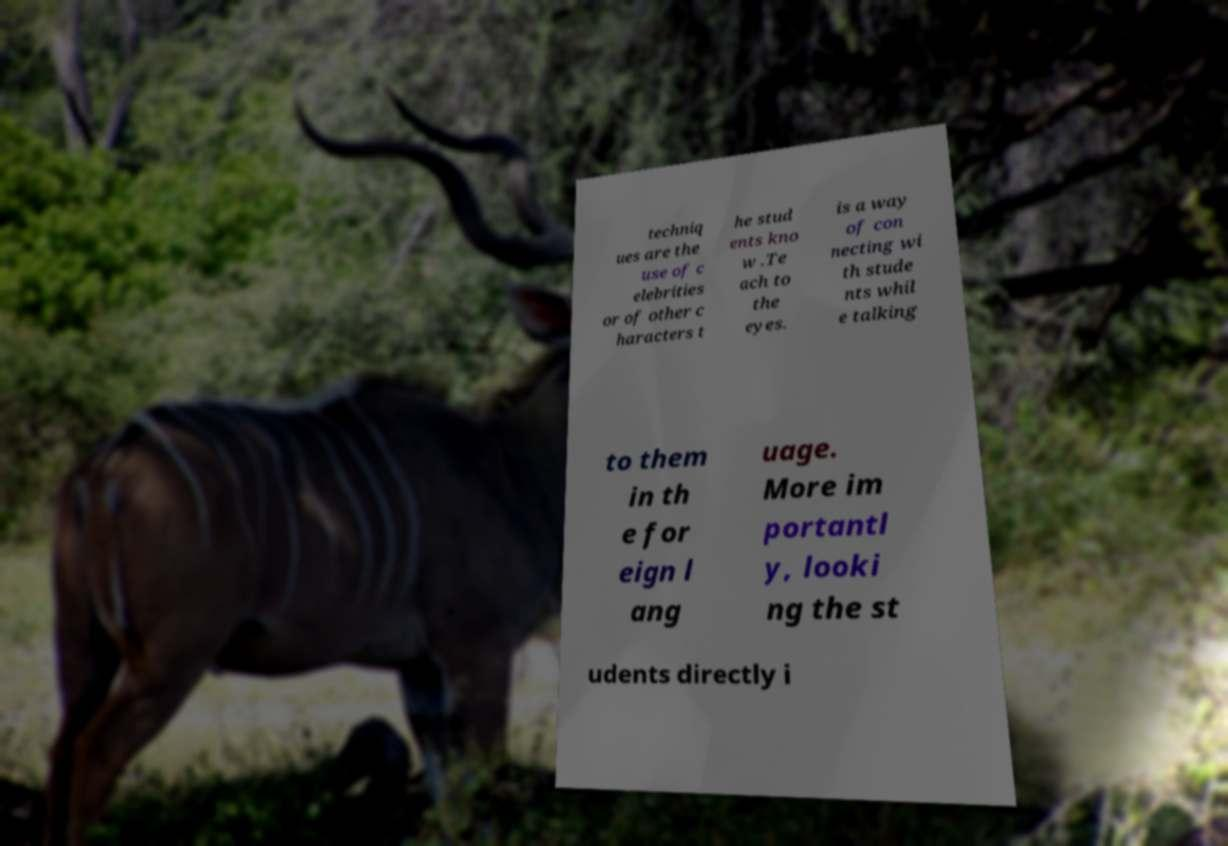What messages or text are displayed in this image? I need them in a readable, typed format. techniq ues are the use of c elebrities or of other c haracters t he stud ents kno w .Te ach to the eyes. is a way of con necting wi th stude nts whil e talking to them in th e for eign l ang uage. More im portantl y, looki ng the st udents directly i 